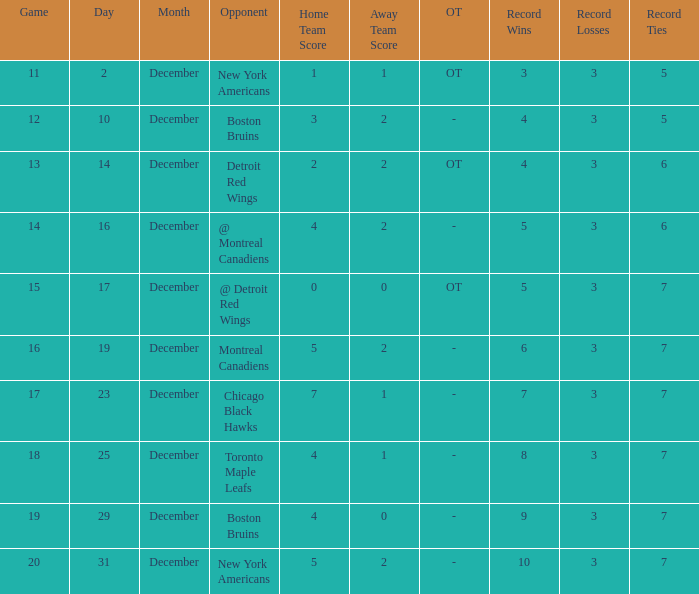Which Game is the highest one that has a Record of 4-3-6? 13.0. 